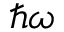Convert formula to latex. <formula><loc_0><loc_0><loc_500><loc_500>\hbar { \omega }</formula> 